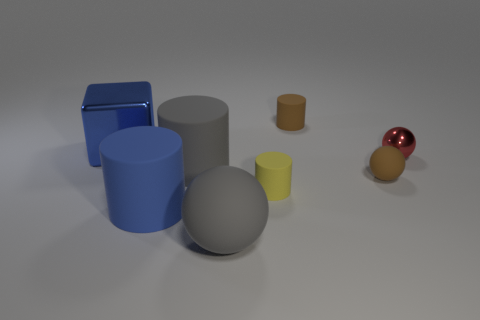Are there any tiny rubber balls of the same color as the large cube?
Keep it short and to the point. No. There is a rubber thing that is behind the blue metallic cube; does it have the same color as the tiny rubber cylinder that is in front of the large blue metal cube?
Keep it short and to the point. No. What number of other things are the same shape as the yellow rubber thing?
Provide a short and direct response. 3. Are there any small yellow metallic balls?
Provide a short and direct response. No. What number of objects are big gray cylinders or large gray cylinders in front of the blue shiny block?
Your answer should be very brief. 1. There is a gray thing in front of the blue matte thing; is its size the same as the large cube?
Keep it short and to the point. Yes. The small metallic object has what color?
Your response must be concise. Red. What is the brown object that is behind the small metal ball made of?
Ensure brevity in your answer.  Rubber. Are there the same number of brown rubber things that are left of the block and large yellow balls?
Your response must be concise. Yes. Is the tiny yellow thing the same shape as the tiny metal thing?
Offer a terse response. No. 